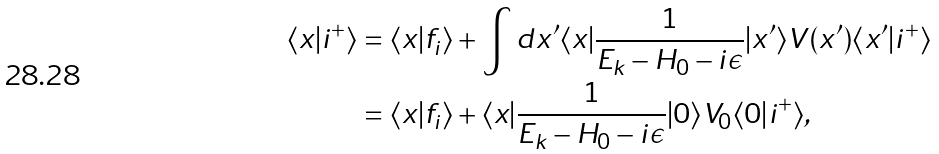<formula> <loc_0><loc_0><loc_500><loc_500>\langle x | i ^ { + } \rangle & = \langle x | f _ { i } \rangle + \int d x ^ { \prime } \langle x | \frac { 1 } { E _ { k } - H _ { 0 } - i \epsilon } | x ^ { \prime } \rangle V ( x ^ { \prime } ) \langle x ^ { \prime } | i ^ { + } \rangle \\ & = \langle x | f _ { i } \rangle + \langle x | \frac { 1 } { E _ { k } - H _ { 0 } - i \epsilon } | 0 \rangle V _ { 0 } \langle 0 | i ^ { + } \rangle ,</formula> 